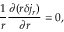Convert formula to latex. <formula><loc_0><loc_0><loc_500><loc_500>\frac { 1 } { r } \frac { \partial ( r \delta j _ { r } ) } { \partial r } = 0 ,</formula> 